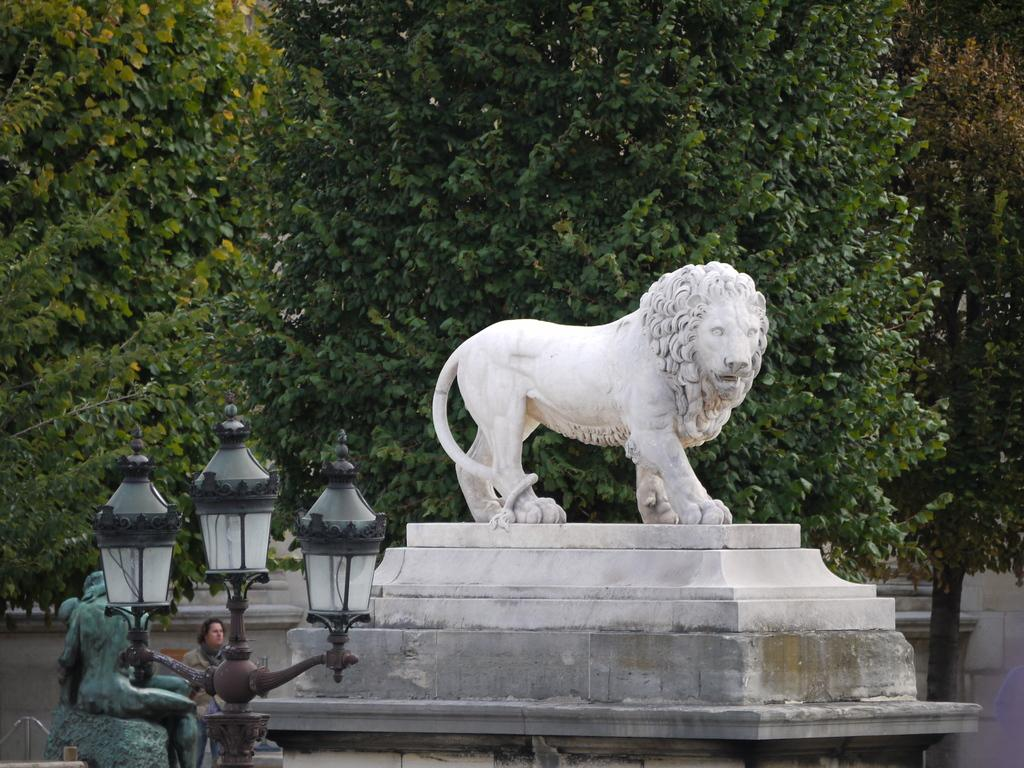What type of sculpture can be seen in the image? There is an animal sculpture in the image. What color is the sculpture at the bottom of the image? There is a green color sculpture at the bottom of the image. What can be seen illuminating the scene in the image? Lights are present in the image. Who is present in the image? There is a person in the image. What type of natural elements can be seen at the top of the image? Trees are visible at the top of the image. How does the person in the image support the hole in the sculpture? There is no hole present in the sculpture in the image, and therefore no support is needed. What type of conversation is the person in the image having with the animal sculpture? There is no conversation taking place between the person and the animal sculpture in the image. 